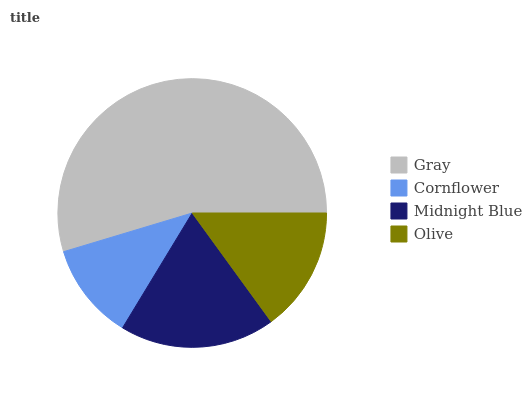Is Cornflower the minimum?
Answer yes or no. Yes. Is Gray the maximum?
Answer yes or no. Yes. Is Midnight Blue the minimum?
Answer yes or no. No. Is Midnight Blue the maximum?
Answer yes or no. No. Is Midnight Blue greater than Cornflower?
Answer yes or no. Yes. Is Cornflower less than Midnight Blue?
Answer yes or no. Yes. Is Cornflower greater than Midnight Blue?
Answer yes or no. No. Is Midnight Blue less than Cornflower?
Answer yes or no. No. Is Midnight Blue the high median?
Answer yes or no. Yes. Is Olive the low median?
Answer yes or no. Yes. Is Olive the high median?
Answer yes or no. No. Is Cornflower the low median?
Answer yes or no. No. 